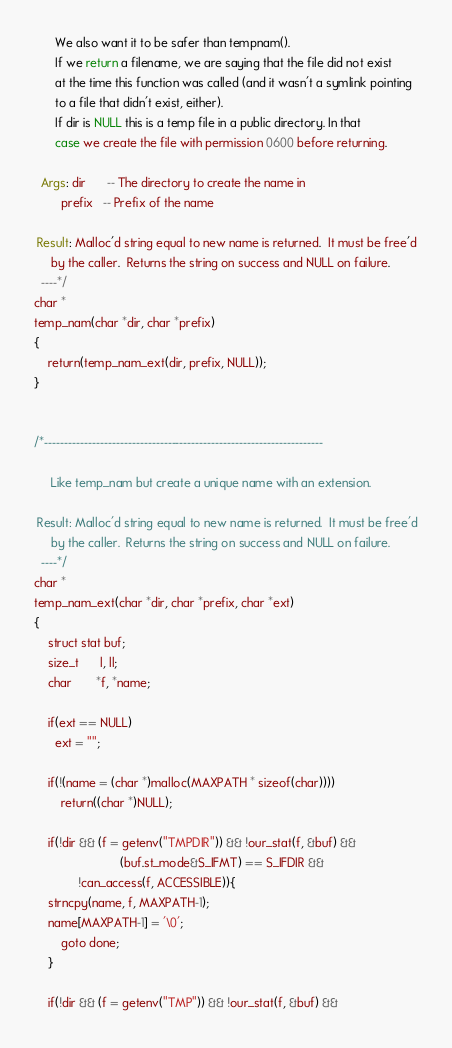<code> <loc_0><loc_0><loc_500><loc_500><_C_>      We also want it to be safer than tempnam().
      If we return a filename, we are saying that the file did not exist
      at the time this function was called (and it wasn't a symlink pointing
      to a file that didn't exist, either).
      If dir is NULL this is a temp file in a public directory. In that
      case we create the file with permission 0600 before returning.

  Args: dir      -- The directory to create the name in
        prefix   -- Prefix of the name
 
 Result: Malloc'd string equal to new name is returned.  It must be free'd
	 by the caller.  Returns the string on success and NULL on failure.
  ----*/
char *
temp_nam(char *dir, char *prefix)
{
    return(temp_nam_ext(dir, prefix, NULL));
}


/*----------------------------------------------------------------------

     Like temp_nam but create a unique name with an extension.
 
 Result: Malloc'd string equal to new name is returned.  It must be free'd
	 by the caller.  Returns the string on success and NULL on failure.
  ----*/
char *
temp_nam_ext(char *dir, char *prefix, char *ext)
{
    struct stat buf;
    size_t      l, ll;
    char       *f, *name;

    if(ext == NULL)
      ext = "";

    if(!(name = (char *)malloc(MAXPATH * sizeof(char))))
        return((char *)NULL);

    if(!dir && (f = getenv("TMPDIR")) && !our_stat(f, &buf) &&
                         (buf.st_mode&S_IFMT) == S_IFDIR &&
			 !can_access(f, ACCESSIBLE)){
	strncpy(name, f, MAXPATH-1);
	name[MAXPATH-1] = '\0';
        goto done;
    }

    if(!dir && (f = getenv("TMP")) && !our_stat(f, &buf) &&</code> 